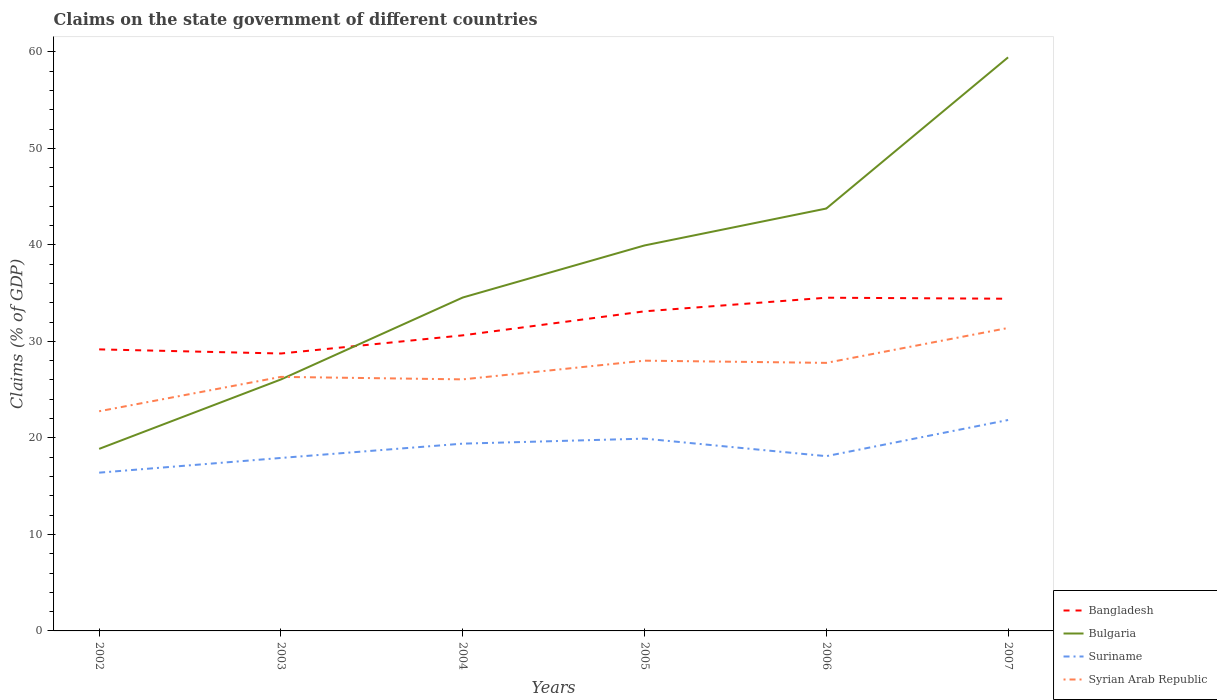How many different coloured lines are there?
Provide a short and direct response. 4. Is the number of lines equal to the number of legend labels?
Ensure brevity in your answer.  Yes. Across all years, what is the maximum percentage of GDP claimed on the state government in Bulgaria?
Provide a succinct answer. 18.86. What is the total percentage of GDP claimed on the state government in Suriname in the graph?
Provide a succinct answer. -1.52. What is the difference between the highest and the second highest percentage of GDP claimed on the state government in Syrian Arab Republic?
Keep it short and to the point. 8.63. How many lines are there?
Offer a terse response. 4. Are the values on the major ticks of Y-axis written in scientific E-notation?
Your response must be concise. No. Does the graph contain grids?
Provide a short and direct response. No. Where does the legend appear in the graph?
Give a very brief answer. Bottom right. How are the legend labels stacked?
Provide a short and direct response. Vertical. What is the title of the graph?
Offer a very short reply. Claims on the state government of different countries. Does "Costa Rica" appear as one of the legend labels in the graph?
Provide a succinct answer. No. What is the label or title of the X-axis?
Keep it short and to the point. Years. What is the label or title of the Y-axis?
Keep it short and to the point. Claims (% of GDP). What is the Claims (% of GDP) of Bangladesh in 2002?
Keep it short and to the point. 29.17. What is the Claims (% of GDP) of Bulgaria in 2002?
Your response must be concise. 18.86. What is the Claims (% of GDP) of Suriname in 2002?
Offer a very short reply. 16.4. What is the Claims (% of GDP) in Syrian Arab Republic in 2002?
Provide a short and direct response. 22.76. What is the Claims (% of GDP) of Bangladesh in 2003?
Your answer should be very brief. 28.74. What is the Claims (% of GDP) in Bulgaria in 2003?
Make the answer very short. 26.06. What is the Claims (% of GDP) in Suriname in 2003?
Your answer should be compact. 17.92. What is the Claims (% of GDP) in Syrian Arab Republic in 2003?
Offer a very short reply. 26.32. What is the Claims (% of GDP) in Bangladesh in 2004?
Give a very brief answer. 30.62. What is the Claims (% of GDP) of Bulgaria in 2004?
Provide a short and direct response. 34.54. What is the Claims (% of GDP) of Suriname in 2004?
Keep it short and to the point. 19.4. What is the Claims (% of GDP) of Syrian Arab Republic in 2004?
Offer a terse response. 26.06. What is the Claims (% of GDP) in Bangladesh in 2005?
Offer a terse response. 33.11. What is the Claims (% of GDP) of Bulgaria in 2005?
Provide a short and direct response. 39.94. What is the Claims (% of GDP) in Suriname in 2005?
Your response must be concise. 19.92. What is the Claims (% of GDP) of Syrian Arab Republic in 2005?
Your answer should be compact. 28. What is the Claims (% of GDP) in Bangladesh in 2006?
Keep it short and to the point. 34.52. What is the Claims (% of GDP) of Bulgaria in 2006?
Give a very brief answer. 43.77. What is the Claims (% of GDP) in Suriname in 2006?
Your answer should be compact. 18.11. What is the Claims (% of GDP) of Syrian Arab Republic in 2006?
Make the answer very short. 27.77. What is the Claims (% of GDP) of Bangladesh in 2007?
Keep it short and to the point. 34.42. What is the Claims (% of GDP) in Bulgaria in 2007?
Ensure brevity in your answer.  59.43. What is the Claims (% of GDP) of Suriname in 2007?
Your answer should be compact. 21.85. What is the Claims (% of GDP) in Syrian Arab Republic in 2007?
Ensure brevity in your answer.  31.39. Across all years, what is the maximum Claims (% of GDP) of Bangladesh?
Give a very brief answer. 34.52. Across all years, what is the maximum Claims (% of GDP) in Bulgaria?
Give a very brief answer. 59.43. Across all years, what is the maximum Claims (% of GDP) of Suriname?
Provide a short and direct response. 21.85. Across all years, what is the maximum Claims (% of GDP) of Syrian Arab Republic?
Your answer should be compact. 31.39. Across all years, what is the minimum Claims (% of GDP) of Bangladesh?
Offer a very short reply. 28.74. Across all years, what is the minimum Claims (% of GDP) in Bulgaria?
Give a very brief answer. 18.86. Across all years, what is the minimum Claims (% of GDP) in Suriname?
Ensure brevity in your answer.  16.4. Across all years, what is the minimum Claims (% of GDP) in Syrian Arab Republic?
Provide a succinct answer. 22.76. What is the total Claims (% of GDP) of Bangladesh in the graph?
Offer a very short reply. 190.6. What is the total Claims (% of GDP) in Bulgaria in the graph?
Offer a terse response. 222.6. What is the total Claims (% of GDP) of Suriname in the graph?
Your answer should be very brief. 113.61. What is the total Claims (% of GDP) of Syrian Arab Republic in the graph?
Ensure brevity in your answer.  162.31. What is the difference between the Claims (% of GDP) in Bangladesh in 2002 and that in 2003?
Offer a terse response. 0.43. What is the difference between the Claims (% of GDP) of Bulgaria in 2002 and that in 2003?
Provide a succinct answer. -7.19. What is the difference between the Claims (% of GDP) of Suriname in 2002 and that in 2003?
Ensure brevity in your answer.  -1.52. What is the difference between the Claims (% of GDP) in Syrian Arab Republic in 2002 and that in 2003?
Your answer should be very brief. -3.56. What is the difference between the Claims (% of GDP) in Bangladesh in 2002 and that in 2004?
Offer a terse response. -1.45. What is the difference between the Claims (% of GDP) in Bulgaria in 2002 and that in 2004?
Your answer should be very brief. -15.68. What is the difference between the Claims (% of GDP) in Suriname in 2002 and that in 2004?
Your answer should be very brief. -3.01. What is the difference between the Claims (% of GDP) in Syrian Arab Republic in 2002 and that in 2004?
Keep it short and to the point. -3.3. What is the difference between the Claims (% of GDP) of Bangladesh in 2002 and that in 2005?
Offer a very short reply. -3.94. What is the difference between the Claims (% of GDP) of Bulgaria in 2002 and that in 2005?
Offer a terse response. -21.08. What is the difference between the Claims (% of GDP) in Suriname in 2002 and that in 2005?
Your answer should be compact. -3.53. What is the difference between the Claims (% of GDP) of Syrian Arab Republic in 2002 and that in 2005?
Ensure brevity in your answer.  -5.24. What is the difference between the Claims (% of GDP) of Bangladesh in 2002 and that in 2006?
Your answer should be very brief. -5.35. What is the difference between the Claims (% of GDP) of Bulgaria in 2002 and that in 2006?
Your answer should be compact. -24.9. What is the difference between the Claims (% of GDP) in Suriname in 2002 and that in 2006?
Your response must be concise. -1.71. What is the difference between the Claims (% of GDP) of Syrian Arab Republic in 2002 and that in 2006?
Your response must be concise. -5.01. What is the difference between the Claims (% of GDP) of Bangladesh in 2002 and that in 2007?
Make the answer very short. -5.25. What is the difference between the Claims (% of GDP) in Bulgaria in 2002 and that in 2007?
Offer a terse response. -40.57. What is the difference between the Claims (% of GDP) in Suriname in 2002 and that in 2007?
Offer a very short reply. -5.46. What is the difference between the Claims (% of GDP) in Syrian Arab Republic in 2002 and that in 2007?
Offer a very short reply. -8.63. What is the difference between the Claims (% of GDP) of Bangladesh in 2003 and that in 2004?
Your answer should be very brief. -1.88. What is the difference between the Claims (% of GDP) of Bulgaria in 2003 and that in 2004?
Offer a very short reply. -8.49. What is the difference between the Claims (% of GDP) of Suriname in 2003 and that in 2004?
Give a very brief answer. -1.48. What is the difference between the Claims (% of GDP) in Syrian Arab Republic in 2003 and that in 2004?
Provide a short and direct response. 0.26. What is the difference between the Claims (% of GDP) of Bangladesh in 2003 and that in 2005?
Provide a succinct answer. -4.37. What is the difference between the Claims (% of GDP) in Bulgaria in 2003 and that in 2005?
Keep it short and to the point. -13.88. What is the difference between the Claims (% of GDP) of Suriname in 2003 and that in 2005?
Keep it short and to the point. -2. What is the difference between the Claims (% of GDP) in Syrian Arab Republic in 2003 and that in 2005?
Your response must be concise. -1.68. What is the difference between the Claims (% of GDP) of Bangladesh in 2003 and that in 2006?
Provide a succinct answer. -5.78. What is the difference between the Claims (% of GDP) of Bulgaria in 2003 and that in 2006?
Ensure brevity in your answer.  -17.71. What is the difference between the Claims (% of GDP) in Suriname in 2003 and that in 2006?
Give a very brief answer. -0.19. What is the difference between the Claims (% of GDP) of Syrian Arab Republic in 2003 and that in 2006?
Your response must be concise. -1.45. What is the difference between the Claims (% of GDP) in Bangladesh in 2003 and that in 2007?
Your answer should be compact. -5.68. What is the difference between the Claims (% of GDP) in Bulgaria in 2003 and that in 2007?
Provide a succinct answer. -33.37. What is the difference between the Claims (% of GDP) in Suriname in 2003 and that in 2007?
Provide a short and direct response. -3.93. What is the difference between the Claims (% of GDP) in Syrian Arab Republic in 2003 and that in 2007?
Your response must be concise. -5.07. What is the difference between the Claims (% of GDP) in Bangladesh in 2004 and that in 2005?
Offer a very short reply. -2.49. What is the difference between the Claims (% of GDP) in Bulgaria in 2004 and that in 2005?
Provide a succinct answer. -5.4. What is the difference between the Claims (% of GDP) in Suriname in 2004 and that in 2005?
Make the answer very short. -0.52. What is the difference between the Claims (% of GDP) of Syrian Arab Republic in 2004 and that in 2005?
Ensure brevity in your answer.  -1.94. What is the difference between the Claims (% of GDP) in Bangladesh in 2004 and that in 2006?
Offer a very short reply. -3.9. What is the difference between the Claims (% of GDP) in Bulgaria in 2004 and that in 2006?
Provide a short and direct response. -9.22. What is the difference between the Claims (% of GDP) in Suriname in 2004 and that in 2006?
Ensure brevity in your answer.  1.3. What is the difference between the Claims (% of GDP) of Syrian Arab Republic in 2004 and that in 2006?
Offer a very short reply. -1.71. What is the difference between the Claims (% of GDP) of Bangladesh in 2004 and that in 2007?
Your response must be concise. -3.79. What is the difference between the Claims (% of GDP) in Bulgaria in 2004 and that in 2007?
Ensure brevity in your answer.  -24.89. What is the difference between the Claims (% of GDP) in Suriname in 2004 and that in 2007?
Provide a succinct answer. -2.45. What is the difference between the Claims (% of GDP) in Syrian Arab Republic in 2004 and that in 2007?
Make the answer very short. -5.33. What is the difference between the Claims (% of GDP) of Bangladesh in 2005 and that in 2006?
Keep it short and to the point. -1.41. What is the difference between the Claims (% of GDP) of Bulgaria in 2005 and that in 2006?
Offer a very short reply. -3.82. What is the difference between the Claims (% of GDP) of Suriname in 2005 and that in 2006?
Provide a short and direct response. 1.82. What is the difference between the Claims (% of GDP) in Syrian Arab Republic in 2005 and that in 2006?
Provide a succinct answer. 0.23. What is the difference between the Claims (% of GDP) in Bangladesh in 2005 and that in 2007?
Offer a terse response. -1.3. What is the difference between the Claims (% of GDP) in Bulgaria in 2005 and that in 2007?
Your answer should be very brief. -19.49. What is the difference between the Claims (% of GDP) in Suriname in 2005 and that in 2007?
Your answer should be very brief. -1.93. What is the difference between the Claims (% of GDP) of Syrian Arab Republic in 2005 and that in 2007?
Provide a short and direct response. -3.39. What is the difference between the Claims (% of GDP) of Bangladesh in 2006 and that in 2007?
Provide a short and direct response. 0.11. What is the difference between the Claims (% of GDP) in Bulgaria in 2006 and that in 2007?
Provide a short and direct response. -15.66. What is the difference between the Claims (% of GDP) in Suriname in 2006 and that in 2007?
Provide a short and direct response. -3.75. What is the difference between the Claims (% of GDP) of Syrian Arab Republic in 2006 and that in 2007?
Ensure brevity in your answer.  -3.62. What is the difference between the Claims (% of GDP) of Bangladesh in 2002 and the Claims (% of GDP) of Bulgaria in 2003?
Provide a succinct answer. 3.12. What is the difference between the Claims (% of GDP) of Bangladesh in 2002 and the Claims (% of GDP) of Suriname in 2003?
Make the answer very short. 11.25. What is the difference between the Claims (% of GDP) in Bangladesh in 2002 and the Claims (% of GDP) in Syrian Arab Republic in 2003?
Provide a short and direct response. 2.85. What is the difference between the Claims (% of GDP) of Bulgaria in 2002 and the Claims (% of GDP) of Suriname in 2003?
Provide a succinct answer. 0.94. What is the difference between the Claims (% of GDP) in Bulgaria in 2002 and the Claims (% of GDP) in Syrian Arab Republic in 2003?
Offer a terse response. -7.46. What is the difference between the Claims (% of GDP) of Suriname in 2002 and the Claims (% of GDP) of Syrian Arab Republic in 2003?
Offer a terse response. -9.92. What is the difference between the Claims (% of GDP) of Bangladesh in 2002 and the Claims (% of GDP) of Bulgaria in 2004?
Offer a terse response. -5.37. What is the difference between the Claims (% of GDP) of Bangladesh in 2002 and the Claims (% of GDP) of Suriname in 2004?
Your response must be concise. 9.77. What is the difference between the Claims (% of GDP) of Bangladesh in 2002 and the Claims (% of GDP) of Syrian Arab Republic in 2004?
Provide a short and direct response. 3.11. What is the difference between the Claims (% of GDP) of Bulgaria in 2002 and the Claims (% of GDP) of Suriname in 2004?
Offer a terse response. -0.54. What is the difference between the Claims (% of GDP) in Bulgaria in 2002 and the Claims (% of GDP) in Syrian Arab Republic in 2004?
Your answer should be compact. -7.2. What is the difference between the Claims (% of GDP) in Suriname in 2002 and the Claims (% of GDP) in Syrian Arab Republic in 2004?
Provide a succinct answer. -9.67. What is the difference between the Claims (% of GDP) of Bangladesh in 2002 and the Claims (% of GDP) of Bulgaria in 2005?
Your response must be concise. -10.77. What is the difference between the Claims (% of GDP) in Bangladesh in 2002 and the Claims (% of GDP) in Suriname in 2005?
Provide a short and direct response. 9.25. What is the difference between the Claims (% of GDP) in Bangladesh in 2002 and the Claims (% of GDP) in Syrian Arab Republic in 2005?
Keep it short and to the point. 1.17. What is the difference between the Claims (% of GDP) of Bulgaria in 2002 and the Claims (% of GDP) of Suriname in 2005?
Your response must be concise. -1.06. What is the difference between the Claims (% of GDP) of Bulgaria in 2002 and the Claims (% of GDP) of Syrian Arab Republic in 2005?
Keep it short and to the point. -9.14. What is the difference between the Claims (% of GDP) in Suriname in 2002 and the Claims (% of GDP) in Syrian Arab Republic in 2005?
Make the answer very short. -11.6. What is the difference between the Claims (% of GDP) in Bangladesh in 2002 and the Claims (% of GDP) in Bulgaria in 2006?
Make the answer very short. -14.59. What is the difference between the Claims (% of GDP) of Bangladesh in 2002 and the Claims (% of GDP) of Suriname in 2006?
Give a very brief answer. 11.06. What is the difference between the Claims (% of GDP) of Bangladesh in 2002 and the Claims (% of GDP) of Syrian Arab Republic in 2006?
Make the answer very short. 1.4. What is the difference between the Claims (% of GDP) in Bulgaria in 2002 and the Claims (% of GDP) in Suriname in 2006?
Offer a very short reply. 0.76. What is the difference between the Claims (% of GDP) in Bulgaria in 2002 and the Claims (% of GDP) in Syrian Arab Republic in 2006?
Your response must be concise. -8.91. What is the difference between the Claims (% of GDP) of Suriname in 2002 and the Claims (% of GDP) of Syrian Arab Republic in 2006?
Make the answer very short. -11.38. What is the difference between the Claims (% of GDP) in Bangladesh in 2002 and the Claims (% of GDP) in Bulgaria in 2007?
Keep it short and to the point. -30.26. What is the difference between the Claims (% of GDP) of Bangladesh in 2002 and the Claims (% of GDP) of Suriname in 2007?
Make the answer very short. 7.32. What is the difference between the Claims (% of GDP) of Bangladesh in 2002 and the Claims (% of GDP) of Syrian Arab Republic in 2007?
Provide a succinct answer. -2.22. What is the difference between the Claims (% of GDP) in Bulgaria in 2002 and the Claims (% of GDP) in Suriname in 2007?
Give a very brief answer. -2.99. What is the difference between the Claims (% of GDP) in Bulgaria in 2002 and the Claims (% of GDP) in Syrian Arab Republic in 2007?
Provide a short and direct response. -12.53. What is the difference between the Claims (% of GDP) in Suriname in 2002 and the Claims (% of GDP) in Syrian Arab Republic in 2007?
Your answer should be compact. -14.99. What is the difference between the Claims (% of GDP) in Bangladesh in 2003 and the Claims (% of GDP) in Bulgaria in 2004?
Provide a succinct answer. -5.8. What is the difference between the Claims (% of GDP) in Bangladesh in 2003 and the Claims (% of GDP) in Suriname in 2004?
Offer a terse response. 9.34. What is the difference between the Claims (% of GDP) in Bangladesh in 2003 and the Claims (% of GDP) in Syrian Arab Republic in 2004?
Offer a terse response. 2.68. What is the difference between the Claims (% of GDP) of Bulgaria in 2003 and the Claims (% of GDP) of Suriname in 2004?
Provide a short and direct response. 6.65. What is the difference between the Claims (% of GDP) of Bulgaria in 2003 and the Claims (% of GDP) of Syrian Arab Republic in 2004?
Provide a succinct answer. -0.01. What is the difference between the Claims (% of GDP) of Suriname in 2003 and the Claims (% of GDP) of Syrian Arab Republic in 2004?
Give a very brief answer. -8.14. What is the difference between the Claims (% of GDP) of Bangladesh in 2003 and the Claims (% of GDP) of Bulgaria in 2005?
Your answer should be very brief. -11.2. What is the difference between the Claims (% of GDP) of Bangladesh in 2003 and the Claims (% of GDP) of Suriname in 2005?
Offer a terse response. 8.82. What is the difference between the Claims (% of GDP) in Bangladesh in 2003 and the Claims (% of GDP) in Syrian Arab Republic in 2005?
Your answer should be compact. 0.74. What is the difference between the Claims (% of GDP) of Bulgaria in 2003 and the Claims (% of GDP) of Suriname in 2005?
Offer a terse response. 6.13. What is the difference between the Claims (% of GDP) in Bulgaria in 2003 and the Claims (% of GDP) in Syrian Arab Republic in 2005?
Offer a very short reply. -1.95. What is the difference between the Claims (% of GDP) in Suriname in 2003 and the Claims (% of GDP) in Syrian Arab Republic in 2005?
Provide a short and direct response. -10.08. What is the difference between the Claims (% of GDP) of Bangladesh in 2003 and the Claims (% of GDP) of Bulgaria in 2006?
Provide a succinct answer. -15.02. What is the difference between the Claims (% of GDP) of Bangladesh in 2003 and the Claims (% of GDP) of Suriname in 2006?
Offer a terse response. 10.64. What is the difference between the Claims (% of GDP) of Bangladesh in 2003 and the Claims (% of GDP) of Syrian Arab Republic in 2006?
Your answer should be very brief. 0.97. What is the difference between the Claims (% of GDP) in Bulgaria in 2003 and the Claims (% of GDP) in Suriname in 2006?
Offer a terse response. 7.95. What is the difference between the Claims (% of GDP) of Bulgaria in 2003 and the Claims (% of GDP) of Syrian Arab Republic in 2006?
Make the answer very short. -1.72. What is the difference between the Claims (% of GDP) in Suriname in 2003 and the Claims (% of GDP) in Syrian Arab Republic in 2006?
Make the answer very short. -9.85. What is the difference between the Claims (% of GDP) in Bangladesh in 2003 and the Claims (% of GDP) in Bulgaria in 2007?
Your response must be concise. -30.69. What is the difference between the Claims (% of GDP) of Bangladesh in 2003 and the Claims (% of GDP) of Suriname in 2007?
Give a very brief answer. 6.89. What is the difference between the Claims (% of GDP) of Bangladesh in 2003 and the Claims (% of GDP) of Syrian Arab Republic in 2007?
Your response must be concise. -2.65. What is the difference between the Claims (% of GDP) of Bulgaria in 2003 and the Claims (% of GDP) of Suriname in 2007?
Your answer should be very brief. 4.2. What is the difference between the Claims (% of GDP) in Bulgaria in 2003 and the Claims (% of GDP) in Syrian Arab Republic in 2007?
Provide a short and direct response. -5.33. What is the difference between the Claims (% of GDP) of Suriname in 2003 and the Claims (% of GDP) of Syrian Arab Republic in 2007?
Give a very brief answer. -13.47. What is the difference between the Claims (% of GDP) of Bangladesh in 2004 and the Claims (% of GDP) of Bulgaria in 2005?
Keep it short and to the point. -9.32. What is the difference between the Claims (% of GDP) of Bangladesh in 2004 and the Claims (% of GDP) of Suriname in 2005?
Give a very brief answer. 10.7. What is the difference between the Claims (% of GDP) of Bangladesh in 2004 and the Claims (% of GDP) of Syrian Arab Republic in 2005?
Offer a terse response. 2.62. What is the difference between the Claims (% of GDP) of Bulgaria in 2004 and the Claims (% of GDP) of Suriname in 2005?
Make the answer very short. 14.62. What is the difference between the Claims (% of GDP) in Bulgaria in 2004 and the Claims (% of GDP) in Syrian Arab Republic in 2005?
Provide a short and direct response. 6.54. What is the difference between the Claims (% of GDP) in Suriname in 2004 and the Claims (% of GDP) in Syrian Arab Republic in 2005?
Offer a very short reply. -8.6. What is the difference between the Claims (% of GDP) of Bangladesh in 2004 and the Claims (% of GDP) of Bulgaria in 2006?
Make the answer very short. -13.14. What is the difference between the Claims (% of GDP) in Bangladesh in 2004 and the Claims (% of GDP) in Suriname in 2006?
Your response must be concise. 12.52. What is the difference between the Claims (% of GDP) in Bangladesh in 2004 and the Claims (% of GDP) in Syrian Arab Republic in 2006?
Your answer should be very brief. 2.85. What is the difference between the Claims (% of GDP) in Bulgaria in 2004 and the Claims (% of GDP) in Suriname in 2006?
Your answer should be very brief. 16.44. What is the difference between the Claims (% of GDP) of Bulgaria in 2004 and the Claims (% of GDP) of Syrian Arab Republic in 2006?
Give a very brief answer. 6.77. What is the difference between the Claims (% of GDP) in Suriname in 2004 and the Claims (% of GDP) in Syrian Arab Republic in 2006?
Provide a short and direct response. -8.37. What is the difference between the Claims (% of GDP) of Bangladesh in 2004 and the Claims (% of GDP) of Bulgaria in 2007?
Your answer should be very brief. -28.81. What is the difference between the Claims (% of GDP) in Bangladesh in 2004 and the Claims (% of GDP) in Suriname in 2007?
Give a very brief answer. 8.77. What is the difference between the Claims (% of GDP) in Bangladesh in 2004 and the Claims (% of GDP) in Syrian Arab Republic in 2007?
Ensure brevity in your answer.  -0.76. What is the difference between the Claims (% of GDP) of Bulgaria in 2004 and the Claims (% of GDP) of Suriname in 2007?
Offer a very short reply. 12.69. What is the difference between the Claims (% of GDP) of Bulgaria in 2004 and the Claims (% of GDP) of Syrian Arab Republic in 2007?
Your response must be concise. 3.15. What is the difference between the Claims (% of GDP) in Suriname in 2004 and the Claims (% of GDP) in Syrian Arab Republic in 2007?
Keep it short and to the point. -11.99. What is the difference between the Claims (% of GDP) of Bangladesh in 2005 and the Claims (% of GDP) of Bulgaria in 2006?
Provide a short and direct response. -10.65. What is the difference between the Claims (% of GDP) in Bangladesh in 2005 and the Claims (% of GDP) in Suriname in 2006?
Offer a very short reply. 15.01. What is the difference between the Claims (% of GDP) of Bangladesh in 2005 and the Claims (% of GDP) of Syrian Arab Republic in 2006?
Provide a succinct answer. 5.34. What is the difference between the Claims (% of GDP) of Bulgaria in 2005 and the Claims (% of GDP) of Suriname in 2006?
Ensure brevity in your answer.  21.83. What is the difference between the Claims (% of GDP) of Bulgaria in 2005 and the Claims (% of GDP) of Syrian Arab Republic in 2006?
Your answer should be compact. 12.17. What is the difference between the Claims (% of GDP) in Suriname in 2005 and the Claims (% of GDP) in Syrian Arab Republic in 2006?
Offer a terse response. -7.85. What is the difference between the Claims (% of GDP) of Bangladesh in 2005 and the Claims (% of GDP) of Bulgaria in 2007?
Offer a very short reply. -26.32. What is the difference between the Claims (% of GDP) in Bangladesh in 2005 and the Claims (% of GDP) in Suriname in 2007?
Provide a short and direct response. 11.26. What is the difference between the Claims (% of GDP) of Bangladesh in 2005 and the Claims (% of GDP) of Syrian Arab Republic in 2007?
Your answer should be compact. 1.72. What is the difference between the Claims (% of GDP) of Bulgaria in 2005 and the Claims (% of GDP) of Suriname in 2007?
Your answer should be very brief. 18.09. What is the difference between the Claims (% of GDP) in Bulgaria in 2005 and the Claims (% of GDP) in Syrian Arab Republic in 2007?
Ensure brevity in your answer.  8.55. What is the difference between the Claims (% of GDP) of Suriname in 2005 and the Claims (% of GDP) of Syrian Arab Republic in 2007?
Offer a very short reply. -11.47. What is the difference between the Claims (% of GDP) of Bangladesh in 2006 and the Claims (% of GDP) of Bulgaria in 2007?
Offer a very short reply. -24.91. What is the difference between the Claims (% of GDP) in Bangladesh in 2006 and the Claims (% of GDP) in Suriname in 2007?
Provide a short and direct response. 12.67. What is the difference between the Claims (% of GDP) of Bangladesh in 2006 and the Claims (% of GDP) of Syrian Arab Republic in 2007?
Ensure brevity in your answer.  3.13. What is the difference between the Claims (% of GDP) of Bulgaria in 2006 and the Claims (% of GDP) of Suriname in 2007?
Your answer should be compact. 21.91. What is the difference between the Claims (% of GDP) in Bulgaria in 2006 and the Claims (% of GDP) in Syrian Arab Republic in 2007?
Your response must be concise. 12.38. What is the difference between the Claims (% of GDP) of Suriname in 2006 and the Claims (% of GDP) of Syrian Arab Republic in 2007?
Your response must be concise. -13.28. What is the average Claims (% of GDP) of Bangladesh per year?
Your answer should be compact. 31.77. What is the average Claims (% of GDP) of Bulgaria per year?
Offer a very short reply. 37.1. What is the average Claims (% of GDP) of Suriname per year?
Your answer should be very brief. 18.93. What is the average Claims (% of GDP) of Syrian Arab Republic per year?
Your answer should be compact. 27.05. In the year 2002, what is the difference between the Claims (% of GDP) of Bangladesh and Claims (% of GDP) of Bulgaria?
Offer a very short reply. 10.31. In the year 2002, what is the difference between the Claims (% of GDP) in Bangladesh and Claims (% of GDP) in Suriname?
Offer a terse response. 12.77. In the year 2002, what is the difference between the Claims (% of GDP) in Bangladesh and Claims (% of GDP) in Syrian Arab Republic?
Offer a very short reply. 6.41. In the year 2002, what is the difference between the Claims (% of GDP) in Bulgaria and Claims (% of GDP) in Suriname?
Make the answer very short. 2.46. In the year 2002, what is the difference between the Claims (% of GDP) in Bulgaria and Claims (% of GDP) in Syrian Arab Republic?
Provide a succinct answer. -3.9. In the year 2002, what is the difference between the Claims (% of GDP) in Suriname and Claims (% of GDP) in Syrian Arab Republic?
Provide a succinct answer. -6.36. In the year 2003, what is the difference between the Claims (% of GDP) of Bangladesh and Claims (% of GDP) of Bulgaria?
Offer a very short reply. 2.69. In the year 2003, what is the difference between the Claims (% of GDP) in Bangladesh and Claims (% of GDP) in Suriname?
Ensure brevity in your answer.  10.82. In the year 2003, what is the difference between the Claims (% of GDP) in Bangladesh and Claims (% of GDP) in Syrian Arab Republic?
Your answer should be very brief. 2.42. In the year 2003, what is the difference between the Claims (% of GDP) in Bulgaria and Claims (% of GDP) in Suriname?
Make the answer very short. 8.13. In the year 2003, what is the difference between the Claims (% of GDP) in Bulgaria and Claims (% of GDP) in Syrian Arab Republic?
Give a very brief answer. -0.27. In the year 2003, what is the difference between the Claims (% of GDP) in Suriname and Claims (% of GDP) in Syrian Arab Republic?
Offer a terse response. -8.4. In the year 2004, what is the difference between the Claims (% of GDP) in Bangladesh and Claims (% of GDP) in Bulgaria?
Provide a short and direct response. -3.92. In the year 2004, what is the difference between the Claims (% of GDP) of Bangladesh and Claims (% of GDP) of Suriname?
Your answer should be compact. 11.22. In the year 2004, what is the difference between the Claims (% of GDP) in Bangladesh and Claims (% of GDP) in Syrian Arab Republic?
Make the answer very short. 4.56. In the year 2004, what is the difference between the Claims (% of GDP) of Bulgaria and Claims (% of GDP) of Suriname?
Offer a terse response. 15.14. In the year 2004, what is the difference between the Claims (% of GDP) in Bulgaria and Claims (% of GDP) in Syrian Arab Republic?
Keep it short and to the point. 8.48. In the year 2004, what is the difference between the Claims (% of GDP) in Suriname and Claims (% of GDP) in Syrian Arab Republic?
Provide a succinct answer. -6.66. In the year 2005, what is the difference between the Claims (% of GDP) in Bangladesh and Claims (% of GDP) in Bulgaria?
Give a very brief answer. -6.83. In the year 2005, what is the difference between the Claims (% of GDP) of Bangladesh and Claims (% of GDP) of Suriname?
Make the answer very short. 13.19. In the year 2005, what is the difference between the Claims (% of GDP) in Bangladesh and Claims (% of GDP) in Syrian Arab Republic?
Give a very brief answer. 5.11. In the year 2005, what is the difference between the Claims (% of GDP) of Bulgaria and Claims (% of GDP) of Suriname?
Offer a very short reply. 20.02. In the year 2005, what is the difference between the Claims (% of GDP) in Bulgaria and Claims (% of GDP) in Syrian Arab Republic?
Your answer should be compact. 11.94. In the year 2005, what is the difference between the Claims (% of GDP) of Suriname and Claims (% of GDP) of Syrian Arab Republic?
Your answer should be compact. -8.08. In the year 2006, what is the difference between the Claims (% of GDP) of Bangladesh and Claims (% of GDP) of Bulgaria?
Offer a very short reply. -9.24. In the year 2006, what is the difference between the Claims (% of GDP) in Bangladesh and Claims (% of GDP) in Suriname?
Offer a terse response. 16.42. In the year 2006, what is the difference between the Claims (% of GDP) of Bangladesh and Claims (% of GDP) of Syrian Arab Republic?
Your response must be concise. 6.75. In the year 2006, what is the difference between the Claims (% of GDP) in Bulgaria and Claims (% of GDP) in Suriname?
Keep it short and to the point. 25.66. In the year 2006, what is the difference between the Claims (% of GDP) in Bulgaria and Claims (% of GDP) in Syrian Arab Republic?
Give a very brief answer. 15.99. In the year 2006, what is the difference between the Claims (% of GDP) of Suriname and Claims (% of GDP) of Syrian Arab Republic?
Your response must be concise. -9.67. In the year 2007, what is the difference between the Claims (% of GDP) of Bangladesh and Claims (% of GDP) of Bulgaria?
Keep it short and to the point. -25.01. In the year 2007, what is the difference between the Claims (% of GDP) in Bangladesh and Claims (% of GDP) in Suriname?
Provide a short and direct response. 12.56. In the year 2007, what is the difference between the Claims (% of GDP) of Bangladesh and Claims (% of GDP) of Syrian Arab Republic?
Ensure brevity in your answer.  3.03. In the year 2007, what is the difference between the Claims (% of GDP) in Bulgaria and Claims (% of GDP) in Suriname?
Provide a succinct answer. 37.58. In the year 2007, what is the difference between the Claims (% of GDP) in Bulgaria and Claims (% of GDP) in Syrian Arab Republic?
Offer a terse response. 28.04. In the year 2007, what is the difference between the Claims (% of GDP) of Suriname and Claims (% of GDP) of Syrian Arab Republic?
Your answer should be very brief. -9.54. What is the ratio of the Claims (% of GDP) in Bangladesh in 2002 to that in 2003?
Ensure brevity in your answer.  1.01. What is the ratio of the Claims (% of GDP) of Bulgaria in 2002 to that in 2003?
Your answer should be compact. 0.72. What is the ratio of the Claims (% of GDP) of Suriname in 2002 to that in 2003?
Provide a succinct answer. 0.91. What is the ratio of the Claims (% of GDP) of Syrian Arab Republic in 2002 to that in 2003?
Give a very brief answer. 0.86. What is the ratio of the Claims (% of GDP) in Bangladesh in 2002 to that in 2004?
Make the answer very short. 0.95. What is the ratio of the Claims (% of GDP) in Bulgaria in 2002 to that in 2004?
Your answer should be very brief. 0.55. What is the ratio of the Claims (% of GDP) in Suriname in 2002 to that in 2004?
Make the answer very short. 0.85. What is the ratio of the Claims (% of GDP) in Syrian Arab Republic in 2002 to that in 2004?
Your answer should be compact. 0.87. What is the ratio of the Claims (% of GDP) of Bangladesh in 2002 to that in 2005?
Your answer should be very brief. 0.88. What is the ratio of the Claims (% of GDP) of Bulgaria in 2002 to that in 2005?
Offer a terse response. 0.47. What is the ratio of the Claims (% of GDP) in Suriname in 2002 to that in 2005?
Provide a succinct answer. 0.82. What is the ratio of the Claims (% of GDP) in Syrian Arab Republic in 2002 to that in 2005?
Your response must be concise. 0.81. What is the ratio of the Claims (% of GDP) of Bangladesh in 2002 to that in 2006?
Give a very brief answer. 0.84. What is the ratio of the Claims (% of GDP) in Bulgaria in 2002 to that in 2006?
Your response must be concise. 0.43. What is the ratio of the Claims (% of GDP) in Suriname in 2002 to that in 2006?
Provide a succinct answer. 0.91. What is the ratio of the Claims (% of GDP) of Syrian Arab Republic in 2002 to that in 2006?
Your answer should be compact. 0.82. What is the ratio of the Claims (% of GDP) of Bangladesh in 2002 to that in 2007?
Provide a short and direct response. 0.85. What is the ratio of the Claims (% of GDP) of Bulgaria in 2002 to that in 2007?
Your answer should be very brief. 0.32. What is the ratio of the Claims (% of GDP) of Suriname in 2002 to that in 2007?
Your answer should be very brief. 0.75. What is the ratio of the Claims (% of GDP) of Syrian Arab Republic in 2002 to that in 2007?
Make the answer very short. 0.73. What is the ratio of the Claims (% of GDP) in Bangladesh in 2003 to that in 2004?
Provide a succinct answer. 0.94. What is the ratio of the Claims (% of GDP) of Bulgaria in 2003 to that in 2004?
Provide a succinct answer. 0.75. What is the ratio of the Claims (% of GDP) of Suriname in 2003 to that in 2004?
Your answer should be very brief. 0.92. What is the ratio of the Claims (% of GDP) in Syrian Arab Republic in 2003 to that in 2004?
Make the answer very short. 1.01. What is the ratio of the Claims (% of GDP) in Bangladesh in 2003 to that in 2005?
Your answer should be very brief. 0.87. What is the ratio of the Claims (% of GDP) of Bulgaria in 2003 to that in 2005?
Give a very brief answer. 0.65. What is the ratio of the Claims (% of GDP) of Suriname in 2003 to that in 2005?
Offer a terse response. 0.9. What is the ratio of the Claims (% of GDP) in Syrian Arab Republic in 2003 to that in 2005?
Your answer should be compact. 0.94. What is the ratio of the Claims (% of GDP) in Bangladesh in 2003 to that in 2006?
Make the answer very short. 0.83. What is the ratio of the Claims (% of GDP) in Bulgaria in 2003 to that in 2006?
Offer a very short reply. 0.6. What is the ratio of the Claims (% of GDP) of Syrian Arab Republic in 2003 to that in 2006?
Give a very brief answer. 0.95. What is the ratio of the Claims (% of GDP) of Bangladesh in 2003 to that in 2007?
Offer a very short reply. 0.84. What is the ratio of the Claims (% of GDP) in Bulgaria in 2003 to that in 2007?
Your response must be concise. 0.44. What is the ratio of the Claims (% of GDP) in Suriname in 2003 to that in 2007?
Your answer should be compact. 0.82. What is the ratio of the Claims (% of GDP) in Syrian Arab Republic in 2003 to that in 2007?
Keep it short and to the point. 0.84. What is the ratio of the Claims (% of GDP) in Bangladesh in 2004 to that in 2005?
Your answer should be compact. 0.92. What is the ratio of the Claims (% of GDP) in Bulgaria in 2004 to that in 2005?
Your answer should be very brief. 0.86. What is the ratio of the Claims (% of GDP) of Suriname in 2004 to that in 2005?
Your response must be concise. 0.97. What is the ratio of the Claims (% of GDP) of Syrian Arab Republic in 2004 to that in 2005?
Give a very brief answer. 0.93. What is the ratio of the Claims (% of GDP) of Bangladesh in 2004 to that in 2006?
Offer a very short reply. 0.89. What is the ratio of the Claims (% of GDP) of Bulgaria in 2004 to that in 2006?
Ensure brevity in your answer.  0.79. What is the ratio of the Claims (% of GDP) of Suriname in 2004 to that in 2006?
Give a very brief answer. 1.07. What is the ratio of the Claims (% of GDP) in Syrian Arab Republic in 2004 to that in 2006?
Make the answer very short. 0.94. What is the ratio of the Claims (% of GDP) in Bangladesh in 2004 to that in 2007?
Offer a very short reply. 0.89. What is the ratio of the Claims (% of GDP) of Bulgaria in 2004 to that in 2007?
Offer a very short reply. 0.58. What is the ratio of the Claims (% of GDP) of Suriname in 2004 to that in 2007?
Your answer should be compact. 0.89. What is the ratio of the Claims (% of GDP) of Syrian Arab Republic in 2004 to that in 2007?
Provide a short and direct response. 0.83. What is the ratio of the Claims (% of GDP) in Bangladesh in 2005 to that in 2006?
Provide a succinct answer. 0.96. What is the ratio of the Claims (% of GDP) in Bulgaria in 2005 to that in 2006?
Your response must be concise. 0.91. What is the ratio of the Claims (% of GDP) in Suriname in 2005 to that in 2006?
Your answer should be compact. 1.1. What is the ratio of the Claims (% of GDP) in Syrian Arab Republic in 2005 to that in 2006?
Offer a terse response. 1.01. What is the ratio of the Claims (% of GDP) of Bangladesh in 2005 to that in 2007?
Ensure brevity in your answer.  0.96. What is the ratio of the Claims (% of GDP) of Bulgaria in 2005 to that in 2007?
Ensure brevity in your answer.  0.67. What is the ratio of the Claims (% of GDP) of Suriname in 2005 to that in 2007?
Ensure brevity in your answer.  0.91. What is the ratio of the Claims (% of GDP) of Syrian Arab Republic in 2005 to that in 2007?
Your answer should be very brief. 0.89. What is the ratio of the Claims (% of GDP) of Bulgaria in 2006 to that in 2007?
Give a very brief answer. 0.74. What is the ratio of the Claims (% of GDP) in Suriname in 2006 to that in 2007?
Your response must be concise. 0.83. What is the ratio of the Claims (% of GDP) of Syrian Arab Republic in 2006 to that in 2007?
Provide a short and direct response. 0.88. What is the difference between the highest and the second highest Claims (% of GDP) of Bangladesh?
Your answer should be very brief. 0.11. What is the difference between the highest and the second highest Claims (% of GDP) of Bulgaria?
Give a very brief answer. 15.66. What is the difference between the highest and the second highest Claims (% of GDP) in Suriname?
Make the answer very short. 1.93. What is the difference between the highest and the second highest Claims (% of GDP) of Syrian Arab Republic?
Ensure brevity in your answer.  3.39. What is the difference between the highest and the lowest Claims (% of GDP) of Bangladesh?
Make the answer very short. 5.78. What is the difference between the highest and the lowest Claims (% of GDP) in Bulgaria?
Offer a terse response. 40.57. What is the difference between the highest and the lowest Claims (% of GDP) in Suriname?
Offer a very short reply. 5.46. What is the difference between the highest and the lowest Claims (% of GDP) in Syrian Arab Republic?
Make the answer very short. 8.63. 